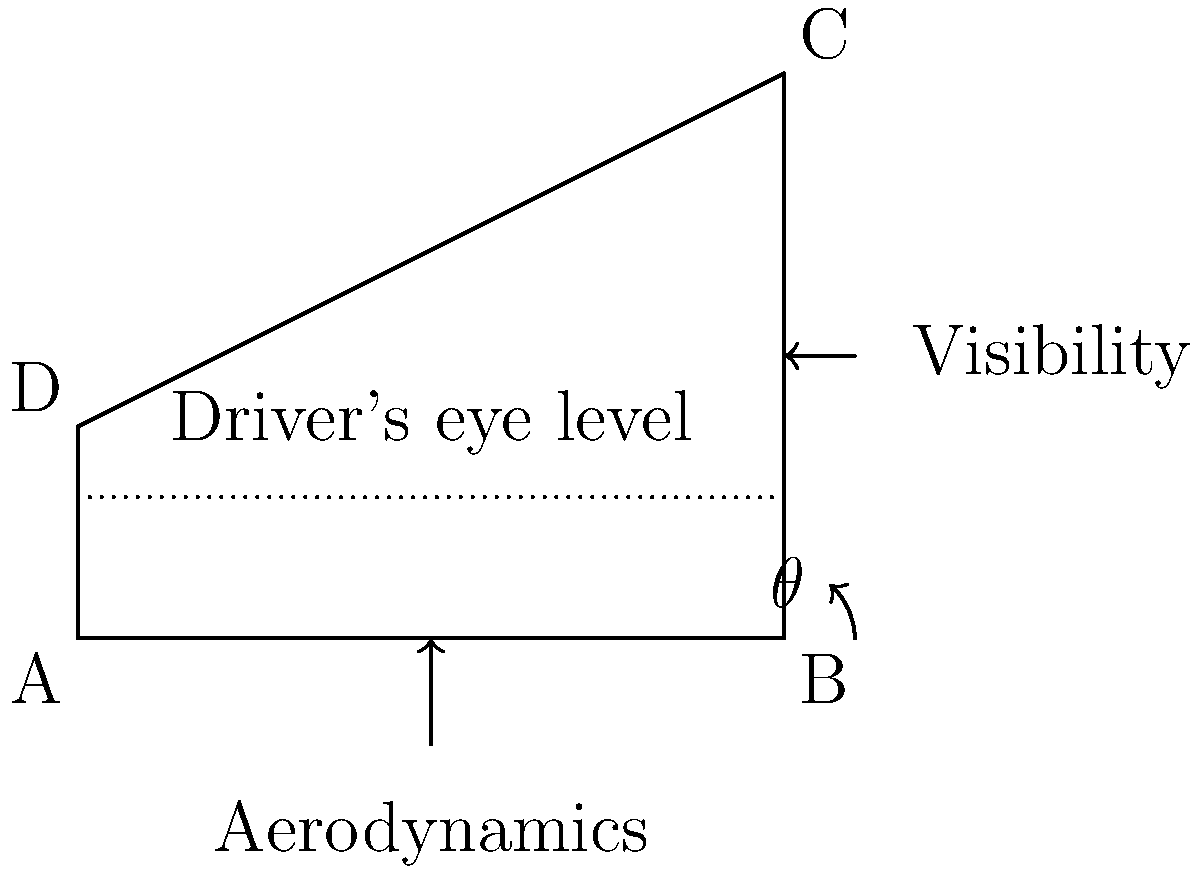As a supercar designer, you're tasked with determining the optimal angle $\theta$ for a sloped windshield that balances aerodynamics and visibility. The windshield spans 10 units horizontally, with its highest point 8 units above the base and its lowest point 3 units above the base. The driver's eye level is 2 units above the base. What is the optimal angle $\theta$ (in degrees) for the windshield, assuming the best compromise between aerodynamics and visibility occurs when the angle bisects the range of possible angles? To solve this problem, we'll follow these steps:

1) First, let's calculate the maximum possible angle (most aerodynamic):
   $\tan(\theta_{max}) = \frac{8-3}{10} = 0.5$
   $\theta_{max} = \arctan(0.5) \approx 26.57°$

2) Now, let's calculate the minimum possible angle (best visibility):
   $\tan(\theta_{min}) = \frac{3-2}{10} = 0.1$
   $\theta_{min} = \arctan(0.1) \approx 5.71°$

3) The optimal angle will be the average of these two:
   $\theta_{optimal} = \frac{\theta_{max} + \theta_{min}}{2}$
   $\theta_{optimal} = \frac{26.57° + 5.71°}{2} \approx 16.14°$

4) To verify, we can calculate the height at the midpoint of the windshield for this angle:
   $h = 3 + 5 \tan(16.14°) \approx 4.45$ units

This height is between the driver's eye level (2 units) and the top of the windshield (8 units), confirming a reasonable compromise between aerodynamics and visibility.
Answer: $16.14°$ 